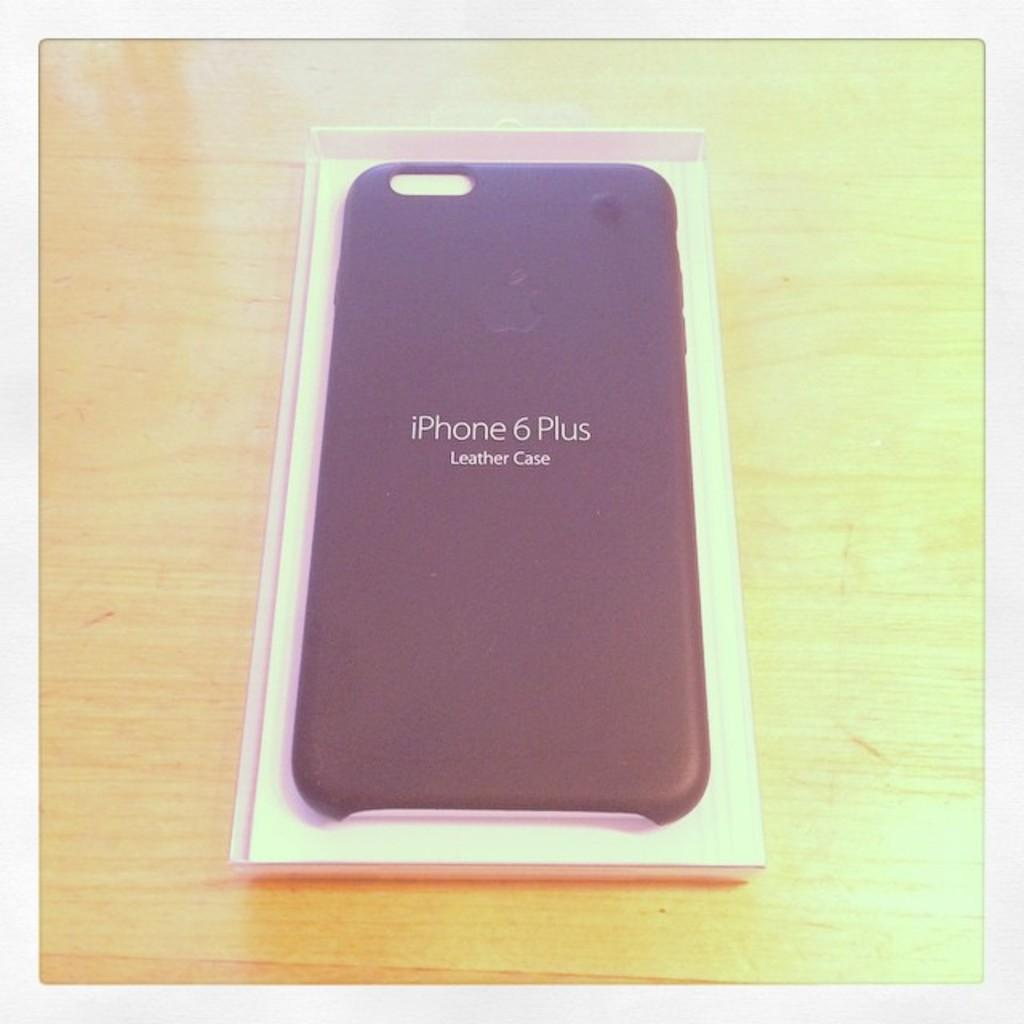<image>
Present a compact description of the photo's key features. In iphone 6 plus with the words leather case underneath. 